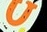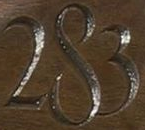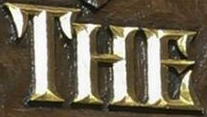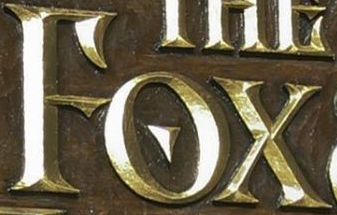What text appears in these images from left to right, separated by a semicolon? U; 283; THE; FOX 